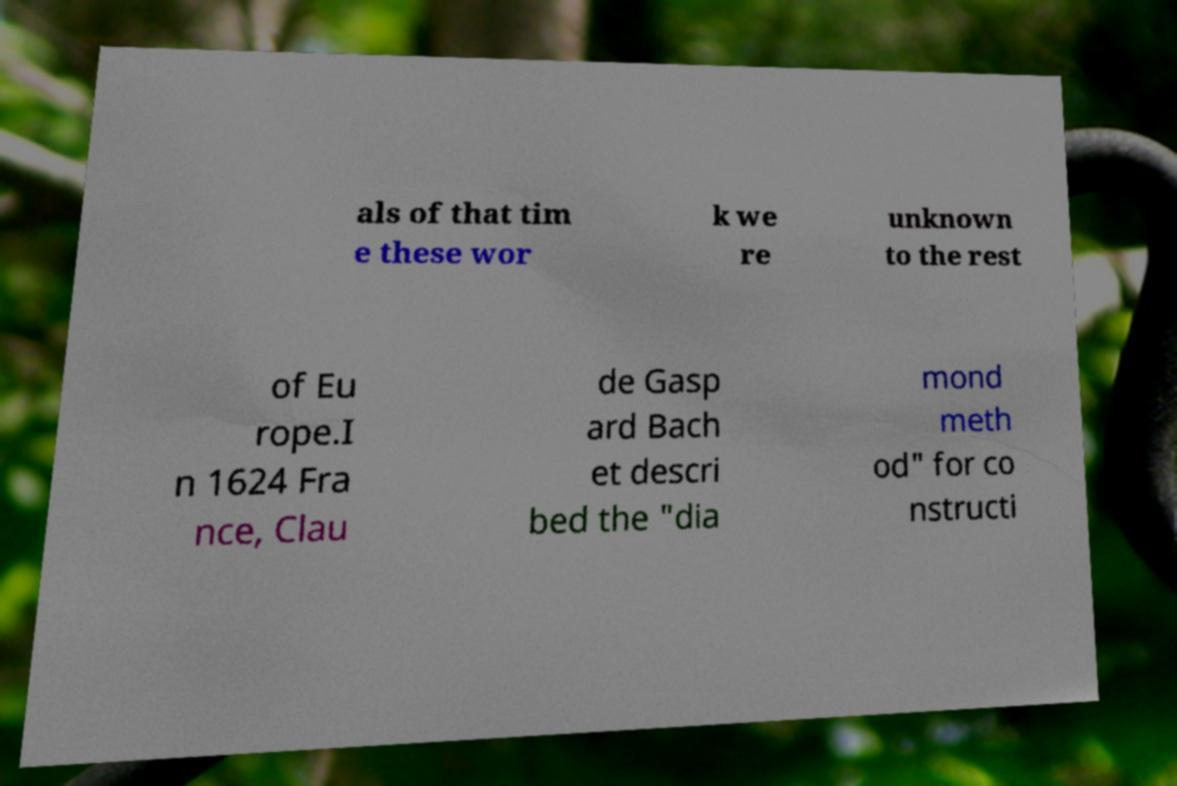Could you assist in decoding the text presented in this image and type it out clearly? als of that tim e these wor k we re unknown to the rest of Eu rope.I n 1624 Fra nce, Clau de Gasp ard Bach et descri bed the "dia mond meth od" for co nstructi 